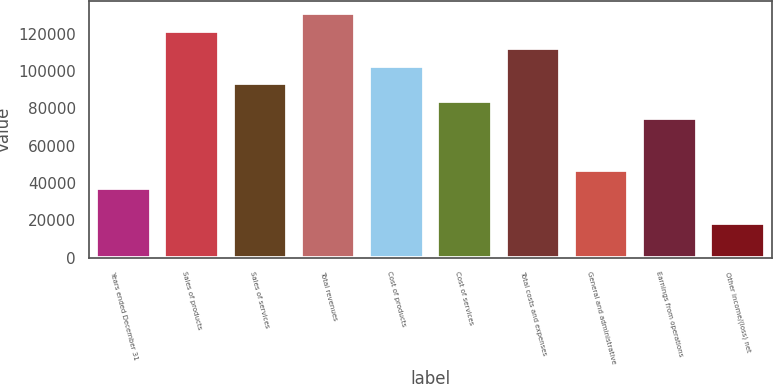Convert chart to OTSL. <chart><loc_0><loc_0><loc_500><loc_500><bar_chart><fcel>Years ended December 31<fcel>Sales of products<fcel>Sales of services<fcel>Total revenues<fcel>Cost of products<fcel>Cost of services<fcel>Total costs and expenses<fcel>General and administrative<fcel>Earnings from operations<fcel>Other income/(loss) net<nl><fcel>37403.1<fcel>121542<fcel>93496<fcel>130891<fcel>102845<fcel>84147.2<fcel>112194<fcel>46751.9<fcel>74798.4<fcel>18705.5<nl></chart> 